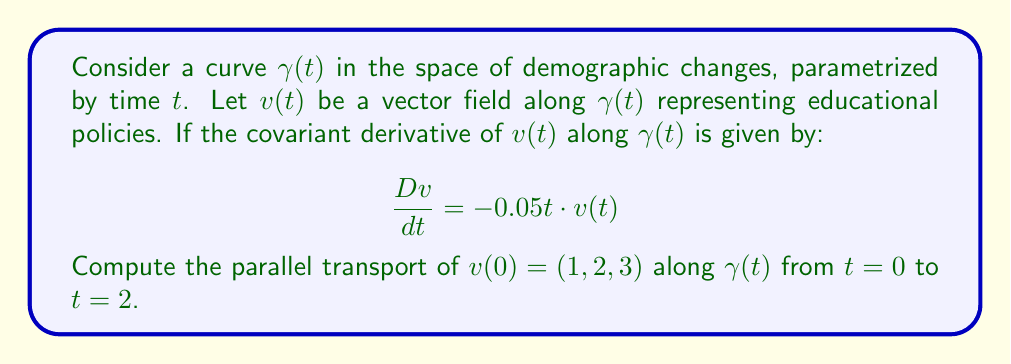Can you answer this question? To solve this problem, we'll follow these steps:

1) Recall that parallel transport requires the covariant derivative to be zero. However, in this case, it's not zero, so we need to solve the differential equation:

   $$\frac{D v}{dt} = -0.05t \cdot v(t)$$

2) This is a first-order linear differential equation. The general solution is:

   $$v(t) = v(0) \cdot e^{-\int 0.05t \, dt}$$

3) Solving the integral:

   $$\int 0.05t \, dt = 0.025t^2 + C$$

4) Therefore, the solution is:

   $$v(t) = v(0) \cdot e^{-0.025t^2}$$

5) We're given $v(0) = (1, 2, 3)$ and need to find $v(2)$:

   $$v(2) = (1, 2, 3) \cdot e^{-0.025 \cdot 2^2} = (1, 2, 3) \cdot e^{-0.1}$$

6) Calculate $e^{-0.1} \approx 0.9048$

7) Therefore:

   $$v(2) \approx (0.9048, 1.8096, 2.7144)$$

This result represents the parallel transport of the initial policy vector along the curve of demographic changes from $t=0$ to $t=2$.
Answer: $(0.9048, 1.8096, 2.7144)$ 